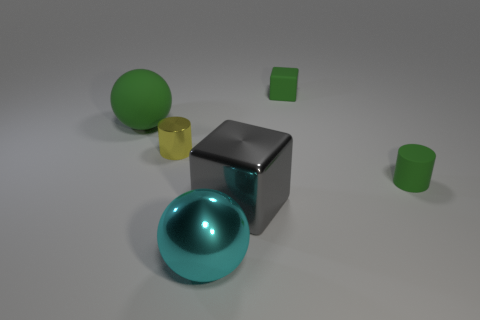Add 2 big objects. How many objects exist? 8 Subtract all cylinders. How many objects are left? 4 Add 5 cyan objects. How many cyan objects exist? 6 Subtract 0 purple cubes. How many objects are left? 6 Subtract all tiny metallic objects. Subtract all red matte things. How many objects are left? 5 Add 5 spheres. How many spheres are left? 7 